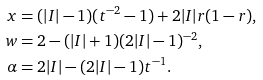Convert formula to latex. <formula><loc_0><loc_0><loc_500><loc_500>x & = ( | I | - 1 ) ( t ^ { - 2 } - 1 ) + 2 | I | r ( 1 - r ) , \\ w & = 2 - ( | I | + 1 ) ( 2 | I | - 1 ) ^ { - 2 } , \\ \alpha & = 2 | I | - ( 2 | I | - 1 ) t ^ { - 1 } .</formula> 